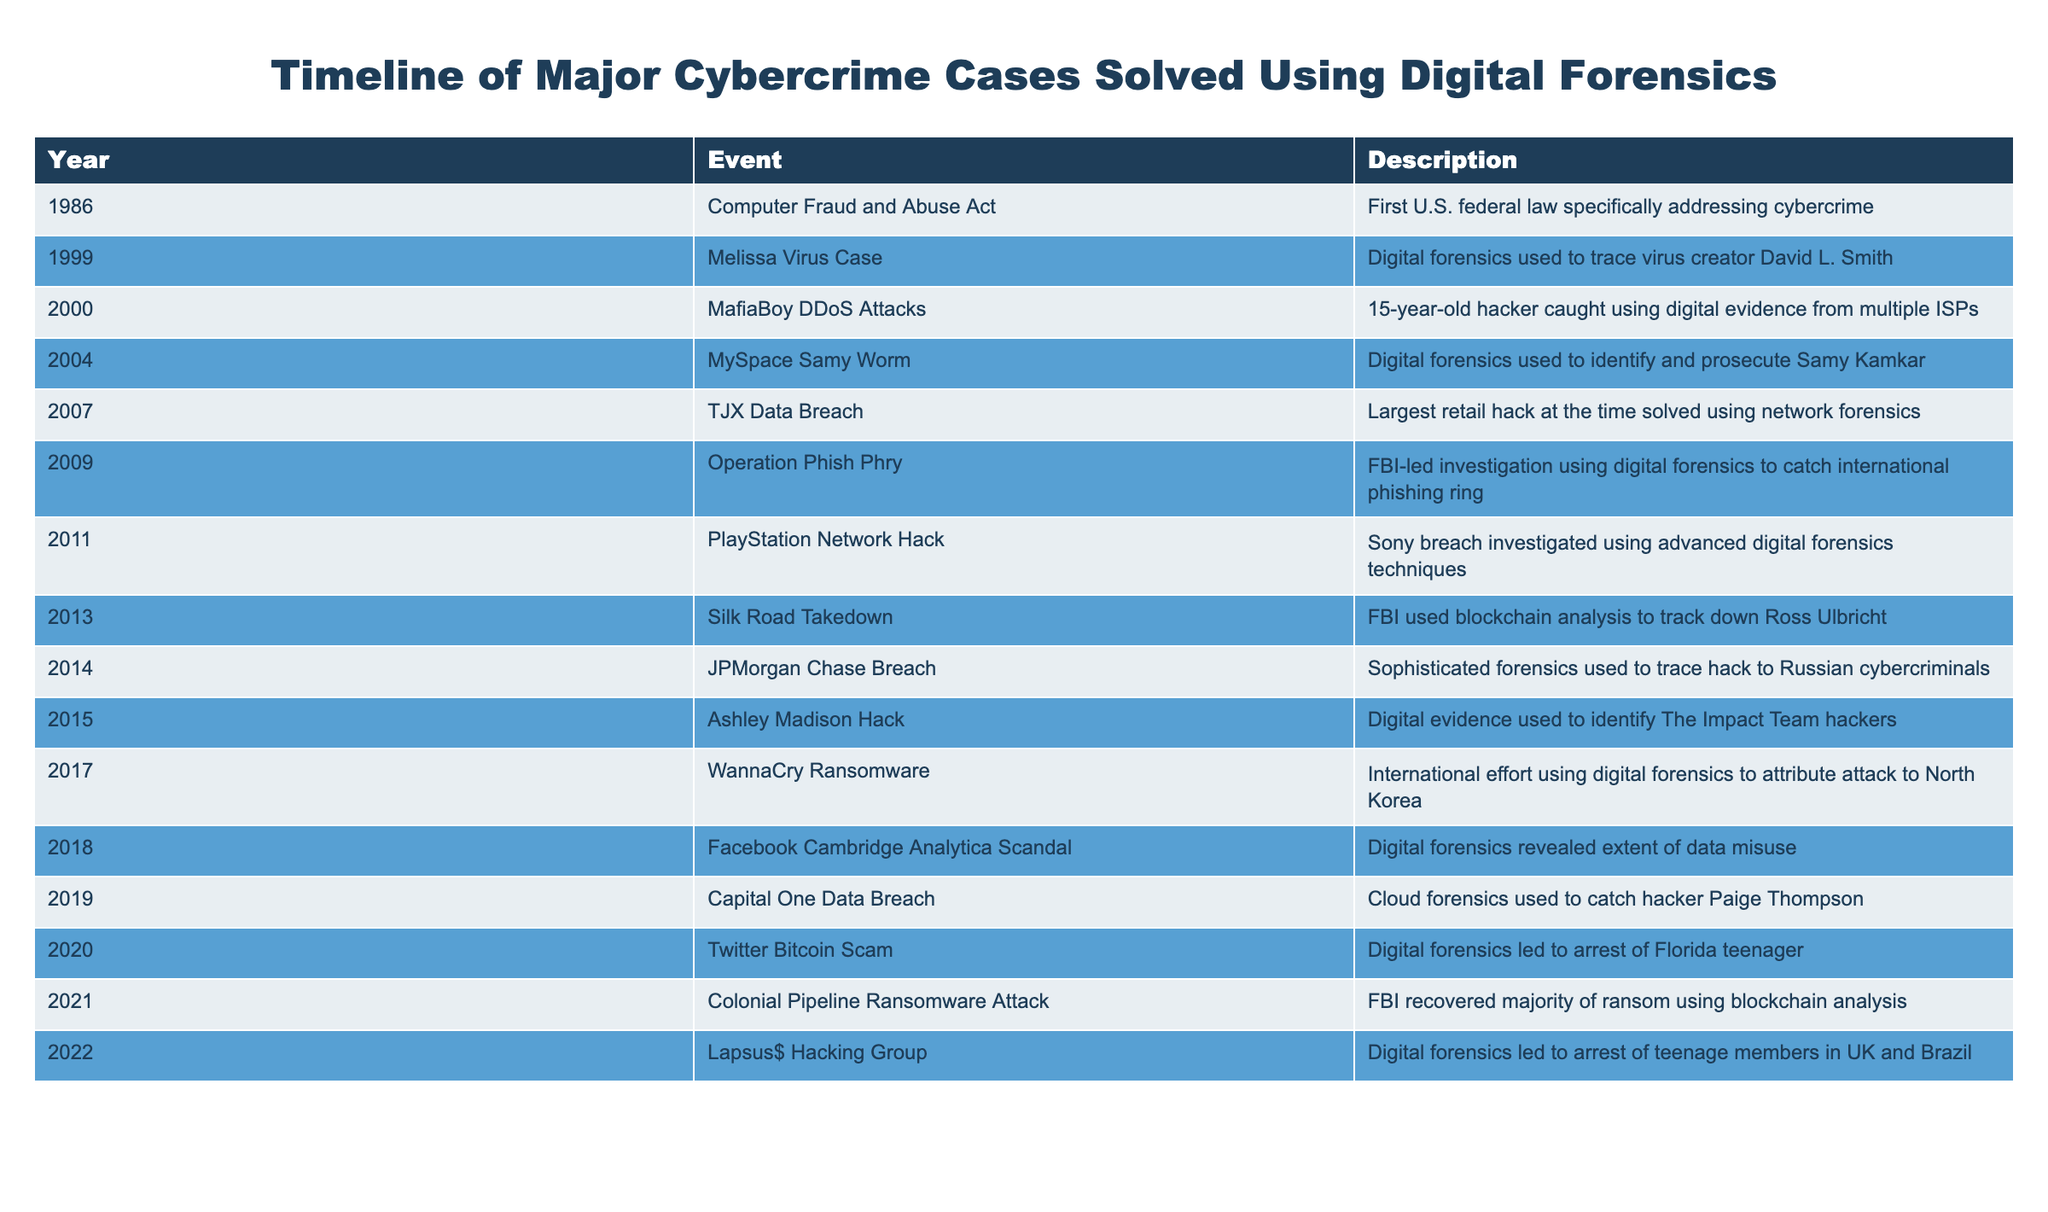What year was the Computer Fraud and Abuse Act enacted? The table directly states that the Computer Fraud and Abuse Act was enacted in 1986.
Answer: 1986 Which cybercrime case used digital forensics to trace the hacker back to an international phishing ring? According to the table, Operation Phish Phry in 2009 involved digital forensics to catch an international phishing ring.
Answer: Operation Phish Phry How many years passed between the Melissa Virus Case and the WannaCry Ransomware attack? The Melissa Virus Case occurred in 1999 and the WannaCry Ransomware attack took place in 2017. The difference is 2017 - 1999 = 18 years.
Answer: 18 years Was the Ashley Madison hack solved through digital forensics? Yes, the table indicates that digital evidence was used to identify the hackers of the Ashley Madison incident in 2015.
Answer: Yes Which case involved the use of blockchain analysis to recover ransom money? The table details that the Colonial Pipeline Ransomware Attack in 2021 involved the FBI recovering the majority of the ransom using blockchain analysis.
Answer: Colonial Pipeline Ransomware Attack How many cases mentioned in the table occurred after 2015? The cases listed after 2015 are the WannaCry Ransomware in 2017, the Cambridge Analytica Scandal in 2018, the Capital One Data Breach in 2019, the Twitter Bitcoin Scam in 2020, and the Colonial Pipeline Ransomware Attack in 2021, which totals 5 cases.
Answer: 5 cases Was there a case in 2004 where digital forensics was used to identify a hacker? Yes, the MySpace Samy Worm case in 2004 used digital forensics to identify and prosecute Samy Kamkar, according to the table.
Answer: Yes What is the average year of the cases listed in the table? To find the average, sum the years (1986 + 1999 + 2000 + 2004 + 2007 + 2009 + 2011 + 2013 + 2014 + 2015 + 2017 + 2018 + 2019 + 2020 + 2021 + 2022 = 2021) and divide by the number of cases (16). The average year is 2021 / 16 = 2009.3125, which we can round to 2009.
Answer: 2009 Which case was the first to apply digital forensics techniques in a significant manner? The table shows that the first significant application of digital forensics was in the 1999 Melissa Virus Case, where the creator was traced using digital forensics.
Answer: Melissa Virus Case 